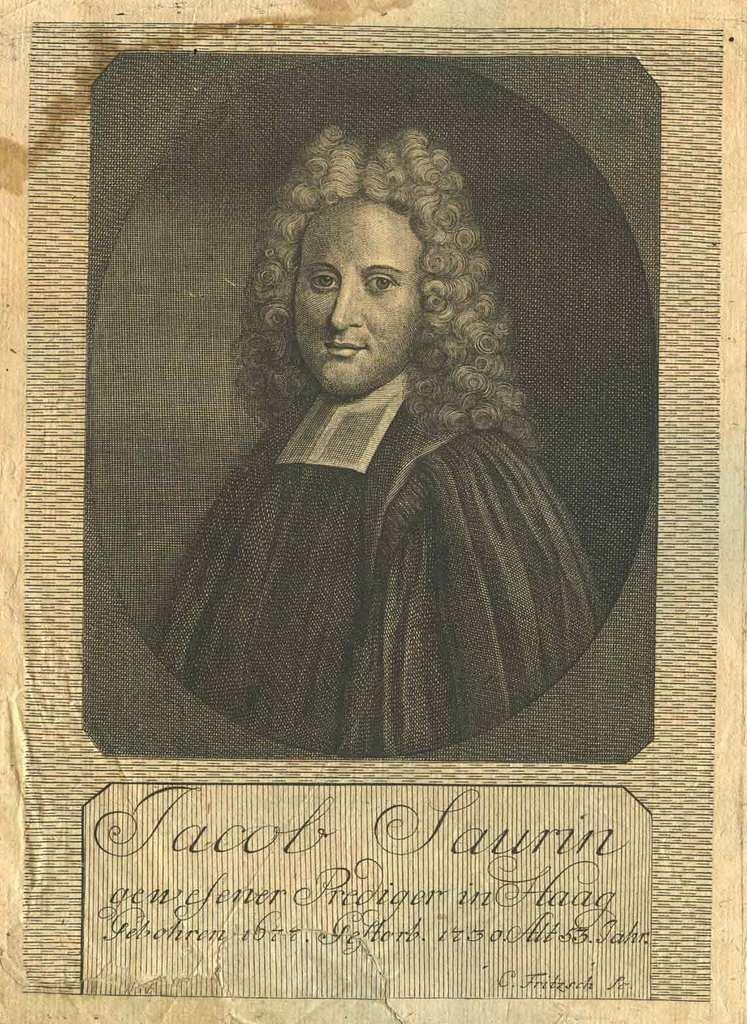What is present on the paper in the image? There is a photo of a person on the paper in the image. What else can be seen on the paper besides the photo? There is writing on the paper. What type of tramp can be seen jumping in the image? There is no tramp present in the image. What color is the powder sprinkled on the top of the paper in the image? There is no powder present on the paper in the image. 